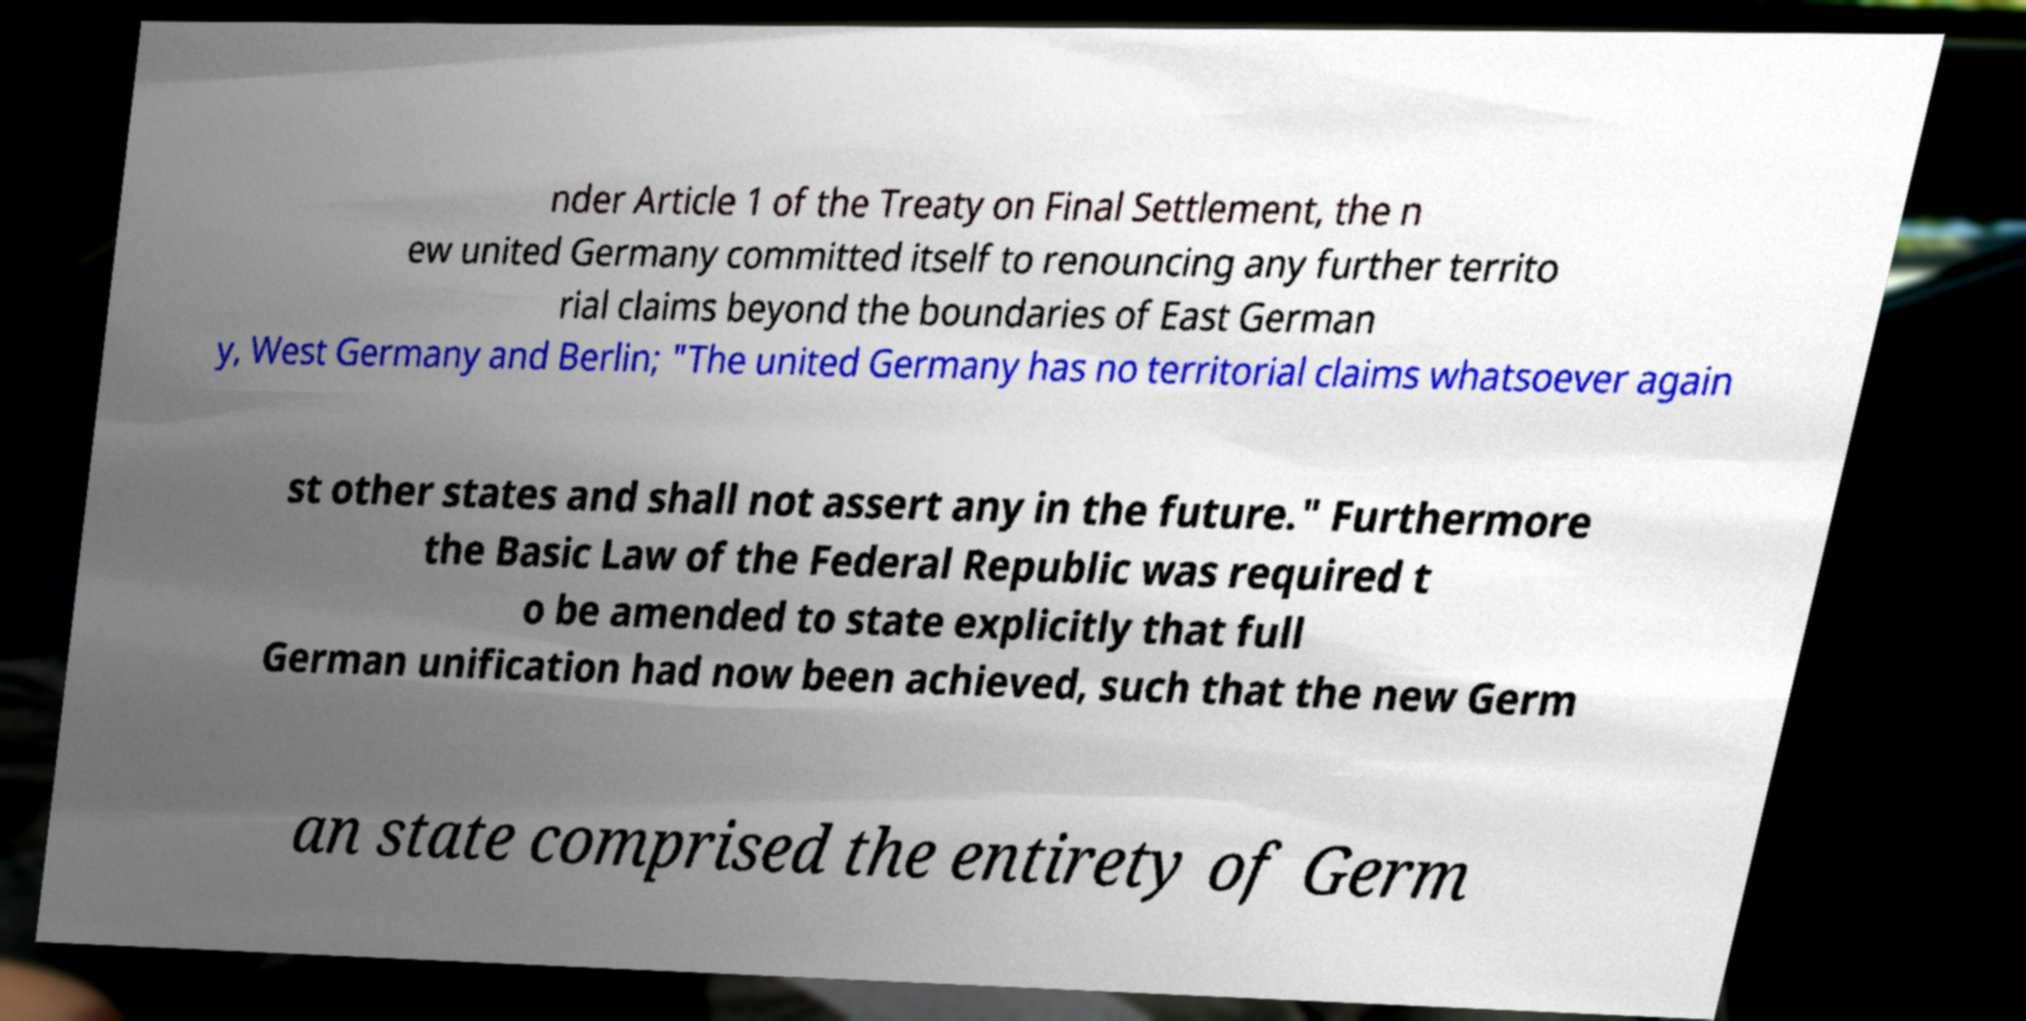What messages or text are displayed in this image? I need them in a readable, typed format. nder Article 1 of the Treaty on Final Settlement, the n ew united Germany committed itself to renouncing any further territo rial claims beyond the boundaries of East German y, West Germany and Berlin; "The united Germany has no territorial claims whatsoever again st other states and shall not assert any in the future." Furthermore the Basic Law of the Federal Republic was required t o be amended to state explicitly that full German unification had now been achieved, such that the new Germ an state comprised the entirety of Germ 